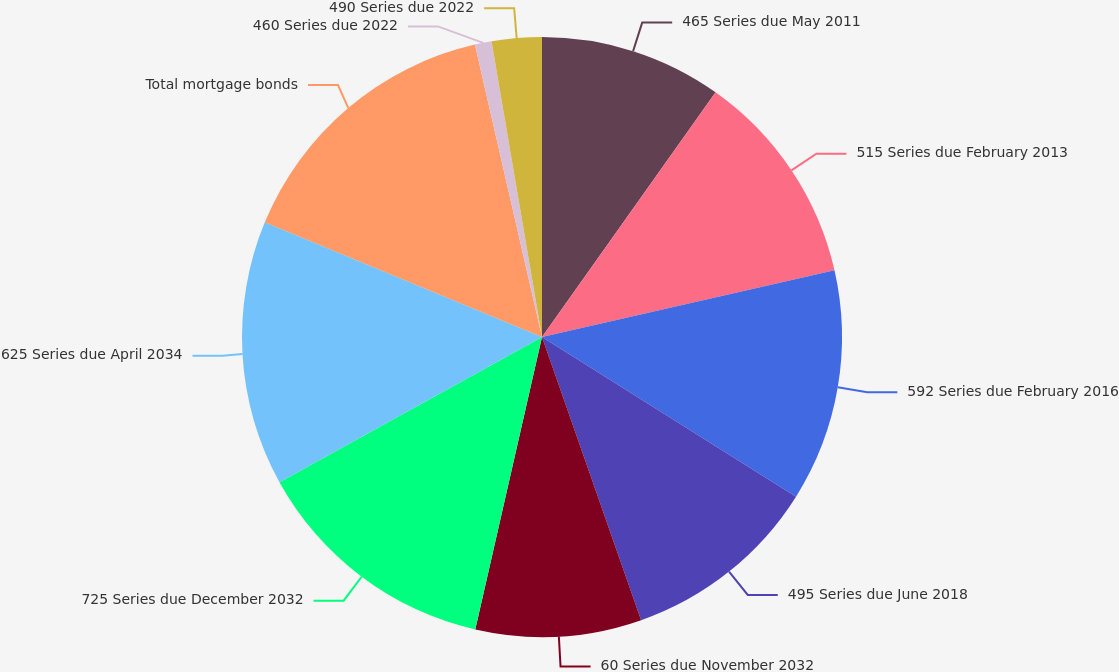Convert chart. <chart><loc_0><loc_0><loc_500><loc_500><pie_chart><fcel>465 Series due May 2011<fcel>515 Series due February 2013<fcel>592 Series due February 2016<fcel>495 Series due June 2018<fcel>60 Series due November 2032<fcel>725 Series due December 2032<fcel>625 Series due April 2034<fcel>Total mortgage bonds<fcel>460 Series due 2022<fcel>490 Series due 2022<nl><fcel>9.82%<fcel>11.61%<fcel>12.5%<fcel>10.71%<fcel>8.93%<fcel>13.39%<fcel>14.28%<fcel>15.17%<fcel>0.9%<fcel>2.69%<nl></chart> 